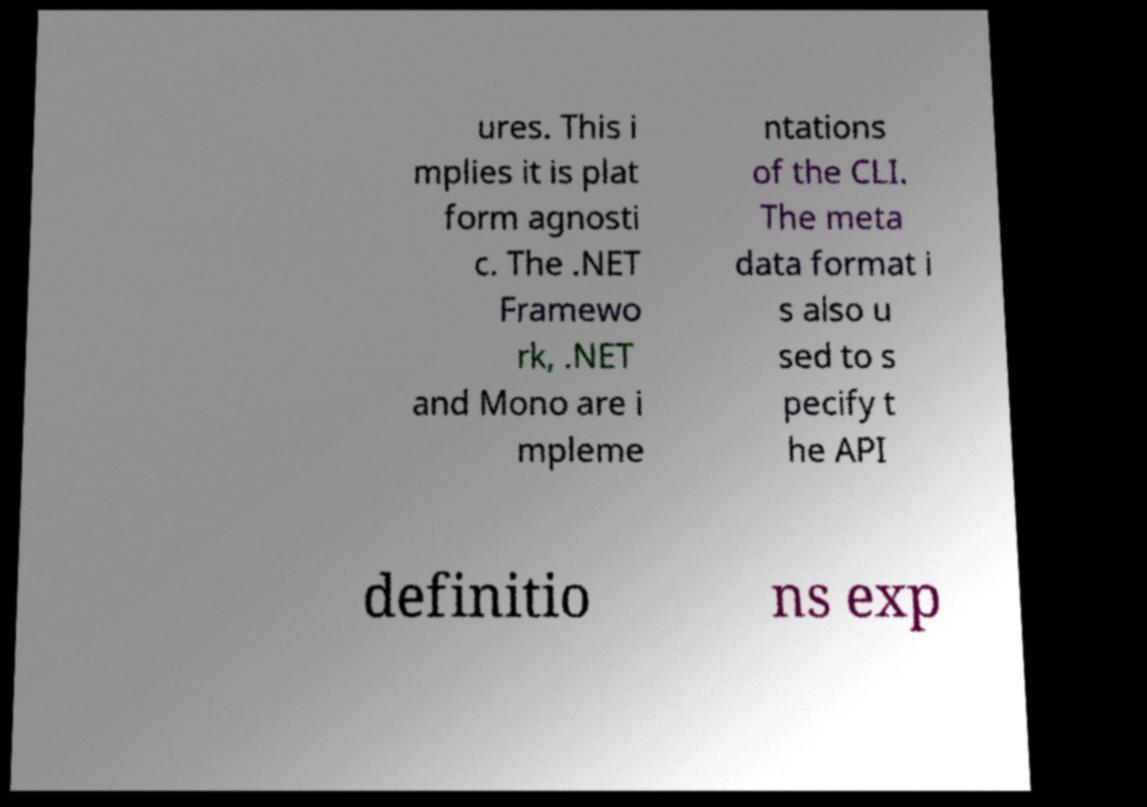I need the written content from this picture converted into text. Can you do that? ures. This i mplies it is plat form agnosti c. The .NET Framewo rk, .NET and Mono are i mpleme ntations of the CLI. The meta data format i s also u sed to s pecify t he API definitio ns exp 